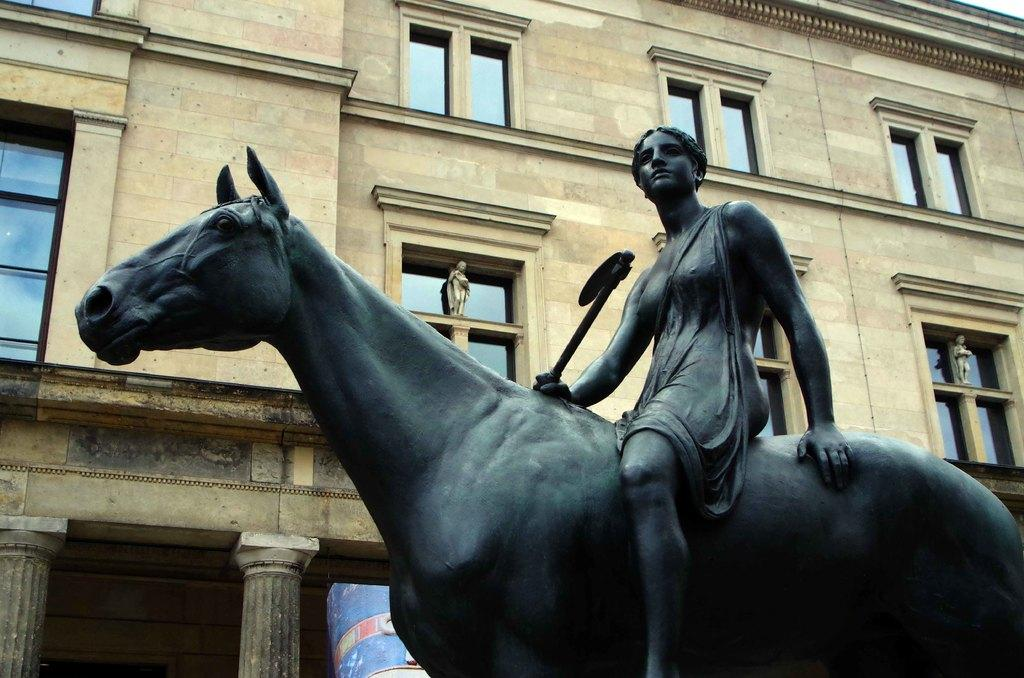What is the main subject of the image? There is a statue of a woman riding a horse in the image. Can you describe the statue in more detail? The statue features a woman riding a horse. What else can be seen in the image besides the statue? There is a building visible in the image. Where is the goldfish swimming in the image? There is no goldfish present in the image. What type of faucet can be seen in the image? There is no faucet present in the image. 